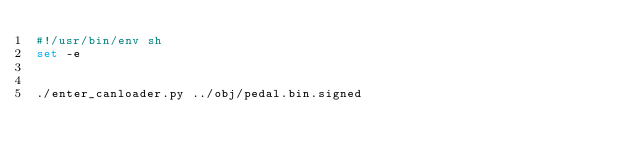<code> <loc_0><loc_0><loc_500><loc_500><_Bash_>#!/usr/bin/env sh
set -e


./enter_canloader.py ../obj/pedal.bin.signed
</code> 